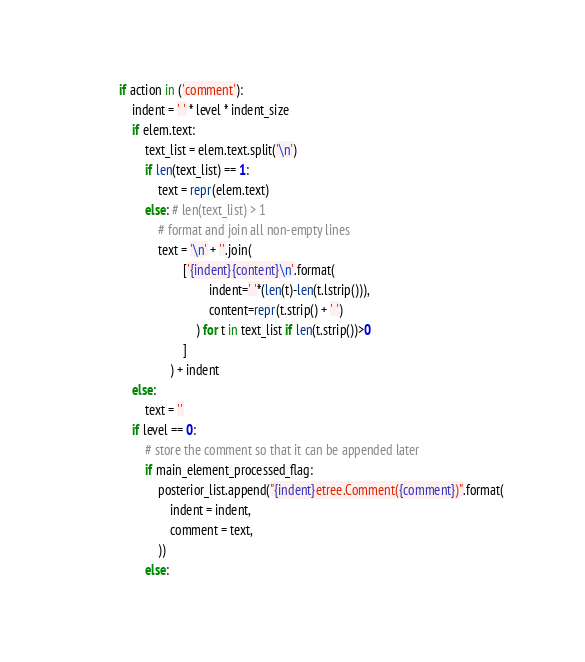<code> <loc_0><loc_0><loc_500><loc_500><_Python_>            if action in ('comment'):
                indent = ' ' * level * indent_size
                if elem.text:
                    text_list = elem.text.split('\n')
                    if len(text_list) == 1:
                        text = repr(elem.text)
                    else: # len(text_list) > 1
                        # format and join all non-empty lines
                        text = '\n' + ''.join(
                                ['{indent}{content}\n'.format(
                                        indent=' '*(len(t)-len(t.lstrip())),
                                        content=repr(t.strip() + ' ')
                                    ) for t in text_list if len(t.strip())>0
                                ]
                            ) + indent
                else:
                    text = ''
                if level == 0:
                    # store the comment so that it can be appended later
                    if main_element_processed_flag:
                        posterior_list.append("{indent}etree.Comment({comment})".format(
                            indent = indent,
                            comment = text,
                        ))
                    else:</code> 